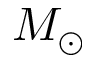Convert formula to latex. <formula><loc_0><loc_0><loc_500><loc_500>M _ { \odot }</formula> 